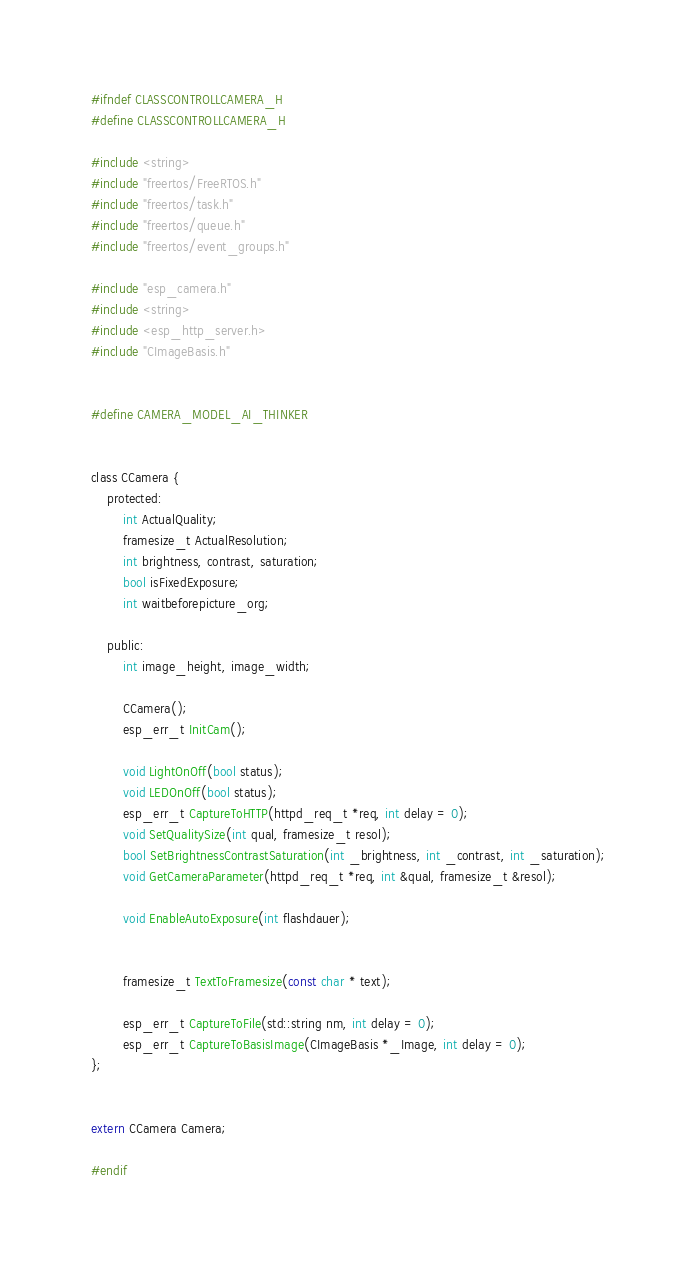<code> <loc_0><loc_0><loc_500><loc_500><_C_>#ifndef CLASSCONTROLLCAMERA_H
#define CLASSCONTROLLCAMERA_H

#include <string>
#include "freertos/FreeRTOS.h"
#include "freertos/task.h"
#include "freertos/queue.h"
#include "freertos/event_groups.h"

#include "esp_camera.h"
#include <string>
#include <esp_http_server.h>
#include "CImageBasis.h"


#define CAMERA_MODEL_AI_THINKER


class CCamera {
    protected:
        int ActualQuality;
        framesize_t ActualResolution;
        int brightness, contrast, saturation;
        bool isFixedExposure;
        int waitbeforepicture_org;

    public:
        int image_height, image_width;
        
        CCamera();
        esp_err_t InitCam();

        void LightOnOff(bool status);
        void LEDOnOff(bool status);
        esp_err_t CaptureToHTTP(httpd_req_t *req, int delay = 0);
        void SetQualitySize(int qual, framesize_t resol);
        bool SetBrightnessContrastSaturation(int _brightness, int _contrast, int _saturation);
        void GetCameraParameter(httpd_req_t *req, int &qual, framesize_t &resol);

        void EnableAutoExposure(int flashdauer);
        

        framesize_t TextToFramesize(const char * text);

        esp_err_t CaptureToFile(std::string nm, int delay = 0);
        esp_err_t CaptureToBasisImage(CImageBasis *_Image, int delay = 0);
};


extern CCamera Camera;

#endif</code> 